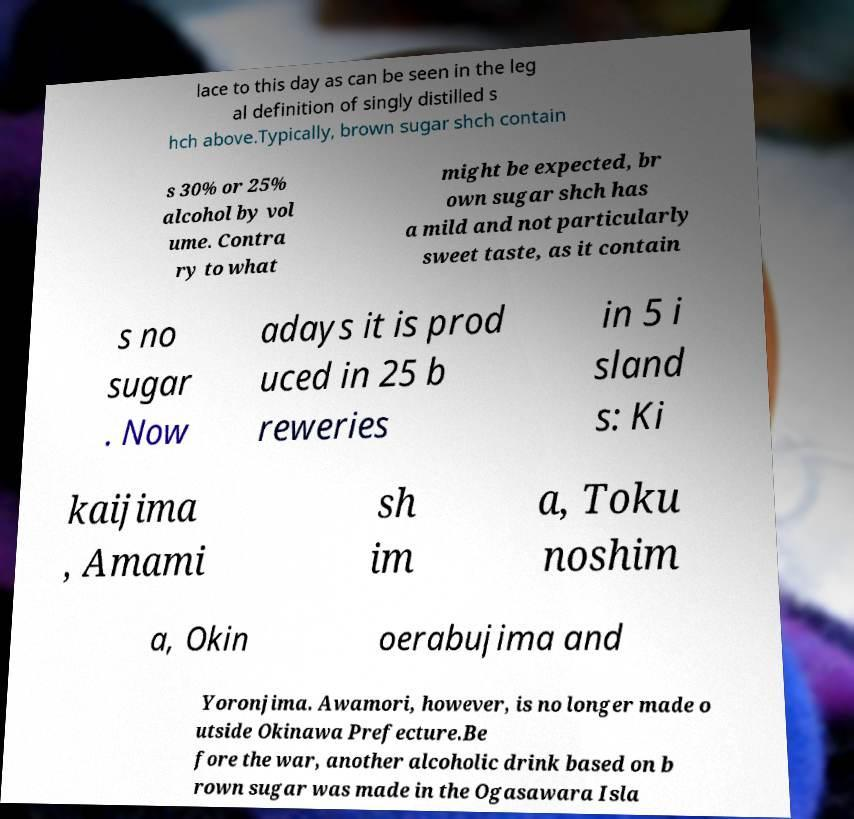Please identify and transcribe the text found in this image. lace to this day as can be seen in the leg al definition of singly distilled s hch above.Typically, brown sugar shch contain s 30% or 25% alcohol by vol ume. Contra ry to what might be expected, br own sugar shch has a mild and not particularly sweet taste, as it contain s no sugar . Now adays it is prod uced in 25 b reweries in 5 i sland s: Ki kaijima , Amami sh im a, Toku noshim a, Okin oerabujima and Yoronjima. Awamori, however, is no longer made o utside Okinawa Prefecture.Be fore the war, another alcoholic drink based on b rown sugar was made in the Ogasawara Isla 